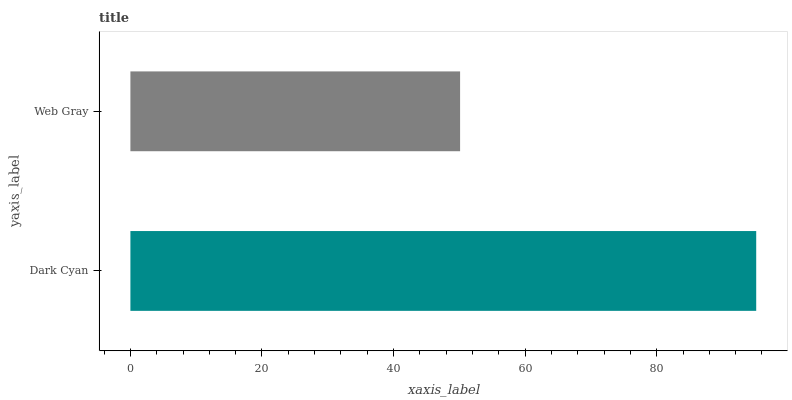Is Web Gray the minimum?
Answer yes or no. Yes. Is Dark Cyan the maximum?
Answer yes or no. Yes. Is Web Gray the maximum?
Answer yes or no. No. Is Dark Cyan greater than Web Gray?
Answer yes or no. Yes. Is Web Gray less than Dark Cyan?
Answer yes or no. Yes. Is Web Gray greater than Dark Cyan?
Answer yes or no. No. Is Dark Cyan less than Web Gray?
Answer yes or no. No. Is Dark Cyan the high median?
Answer yes or no. Yes. Is Web Gray the low median?
Answer yes or no. Yes. Is Web Gray the high median?
Answer yes or no. No. Is Dark Cyan the low median?
Answer yes or no. No. 